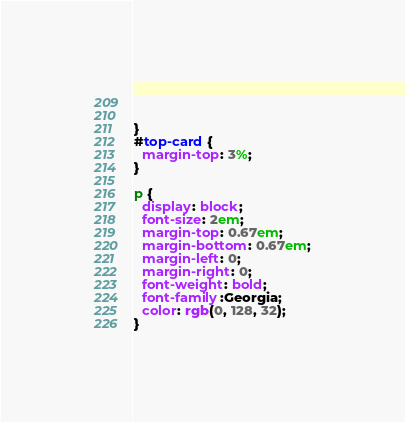Convert code to text. <code><loc_0><loc_0><loc_500><loc_500><_CSS_>  

}
#top-card {
  margin-top: 3%;
}

p { 
  display: block;
  font-size: 2em;
  margin-top: 0.67em;
  margin-bottom: 0.67em;
  margin-left: 0;
  margin-right: 0;
  font-weight: bold;
  font-family:Georgia;
  color: rgb(0, 128, 32);
}</code> 